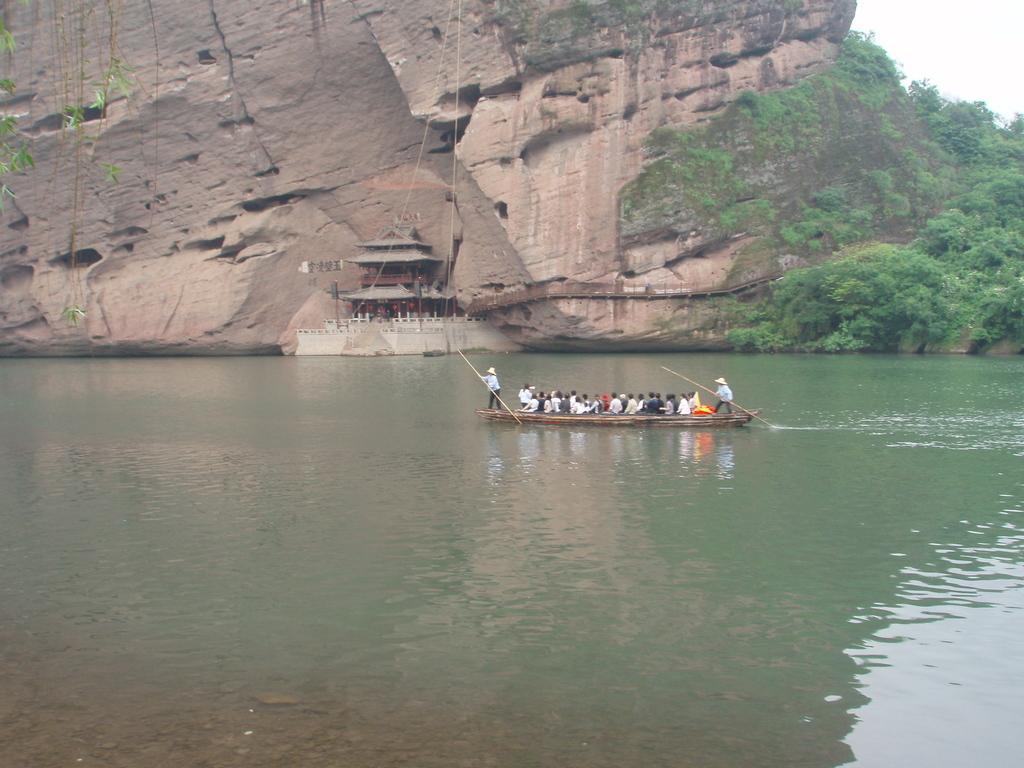Can you describe this image briefly? In the center of the image there are persons in boat sailing on the river. In the background we can see hill, trees, temple and sky. 